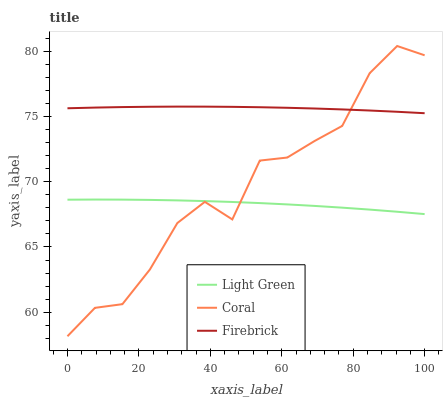Does Firebrick have the minimum area under the curve?
Answer yes or no. No. Does Light Green have the maximum area under the curve?
Answer yes or no. No. Is Light Green the smoothest?
Answer yes or no. No. Is Light Green the roughest?
Answer yes or no. No. Does Light Green have the lowest value?
Answer yes or no. No. Does Firebrick have the highest value?
Answer yes or no. No. Is Light Green less than Firebrick?
Answer yes or no. Yes. Is Firebrick greater than Light Green?
Answer yes or no. Yes. Does Light Green intersect Firebrick?
Answer yes or no. No. 